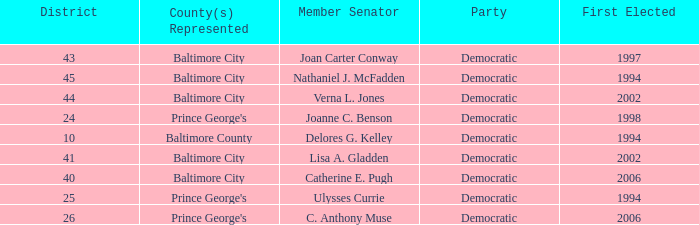In a district larger than 41, who was first elected in 2002? Verna L. Jones. Give me the full table as a dictionary. {'header': ['District', 'County(s) Represented', 'Member Senator', 'Party', 'First Elected'], 'rows': [['43', 'Baltimore City', 'Joan Carter Conway', 'Democratic', '1997'], ['45', 'Baltimore City', 'Nathaniel J. McFadden', 'Democratic', '1994'], ['44', 'Baltimore City', 'Verna L. Jones', 'Democratic', '2002'], ['24', "Prince George's", 'Joanne C. Benson', 'Democratic', '1998'], ['10', 'Baltimore County', 'Delores G. Kelley', 'Democratic', '1994'], ['41', 'Baltimore City', 'Lisa A. Gladden', 'Democratic', '2002'], ['40', 'Baltimore City', 'Catherine E. Pugh', 'Democratic', '2006'], ['25', "Prince George's", 'Ulysses Currie', 'Democratic', '1994'], ['26', "Prince George's", 'C. Anthony Muse', 'Democratic', '2006']]} 